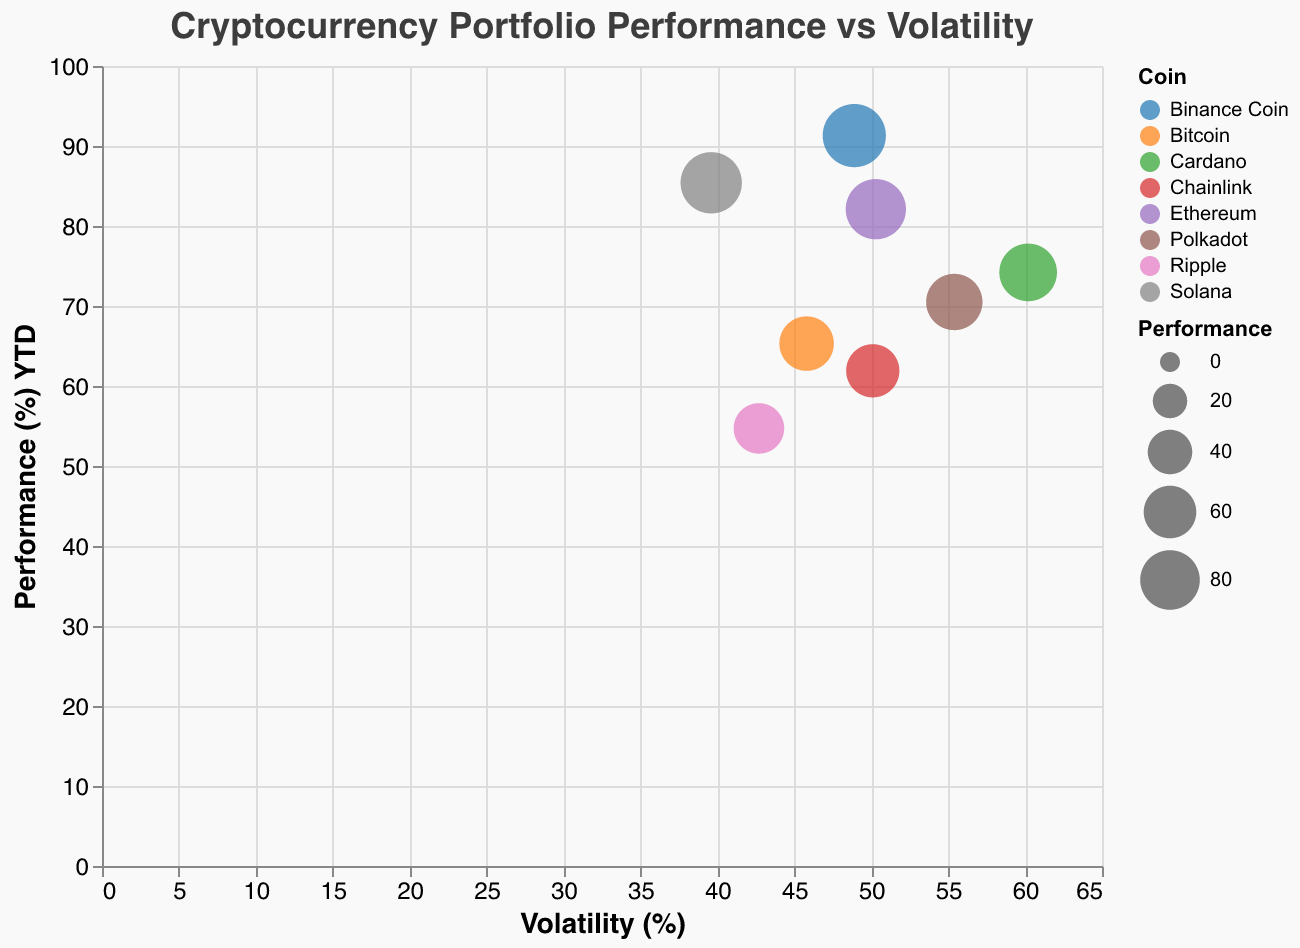What's the title of the chart? The title of the chart is located at the top and is one of the basic visual elements. It provides a brief description of what the chart represents.
Answer: Cryptocurrency Portfolio Performance vs Volatility How many different coins are depicted in the chart? We can determine the number of different coins by counting the distinct colors or the data points, each representing a different coin.
Answer: 8 Which coin has the highest performance? The highest performance can be identified by looking at the y-axis and finding the data point that reaches the highest value, which indicates the best performance percentage.
Answer: Binance Coin Which coin has the lowest volatility? The lowest volatility can be found by locating the data point that is closest to the origin on the x-axis.
Answer: Solana Which coin has the highest volatility but does not have the highest performance? This requires finding the coin with the highest x-value (volatility) but ensuring it is not the same coin with the highest y-value (performance). Cardano has the highest volatility and Binance Coin has the highest performance.
Answer: Cardano What's the average performance of all the coins? To find the average performance, sum up all the performance percentages and divide by the number of data points. The calculation is (65.3 + 82.1 + 74.2 + 54.7 + 70.5 + 91.3 + 85.4 + 61.9) / 8.
Answer: 73.2 Which coins have both performance and volatility above 60%? Look for data points where both the x (volatility) and y (performance) values are above 60%. Cardano, Polkadot, and Ethereum meet this criterion.
Answer: Cardano, Polkadot, Ethereum Compare Bitcoin and Solana in terms of volatility. Which one is more volatile? Compare the x-values (volatility) of Bitcoin and Solana to determine which has a higher percentage. Bitcoin's volatility is 45.8%, whereas Solana's is 39.6%.
Answer: Bitcoin What is the difference between the highest and lowest performances? Subtract the lowest performance percentage from the highest performance percentage. The highest is Binance Coin (91.3%) and the lowest is Ripple (54.7%). The calculation is 91.3 - 54.7.
Answer: 36.6 Looking at the size of the bubbles, which coin has the smallest bubble? The size of the bubble is tied to the performance value. The smallest bubble is Ripple, as it has the lowest performance value.
Answer: Ripple 